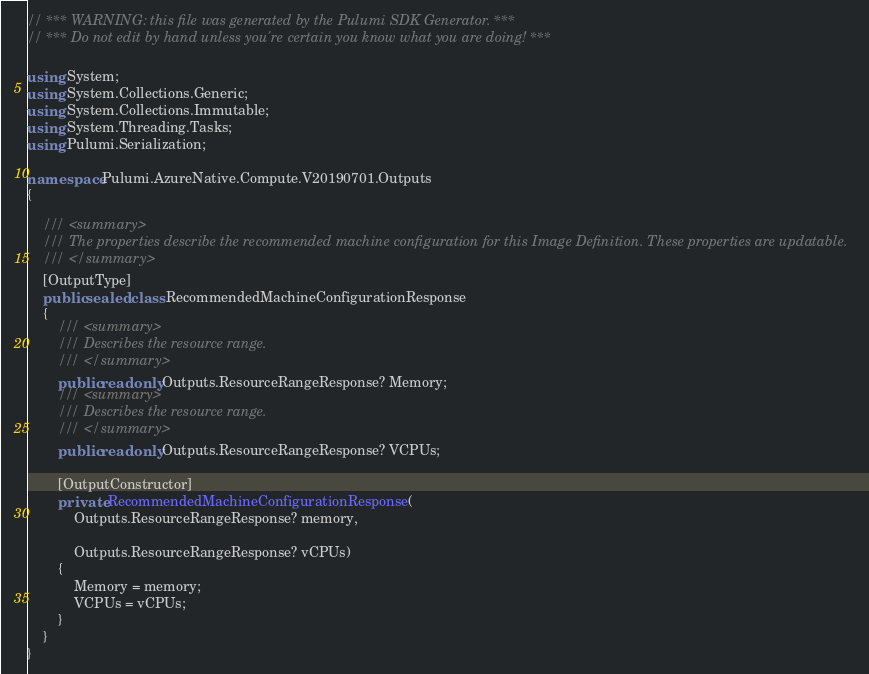Convert code to text. <code><loc_0><loc_0><loc_500><loc_500><_C#_>// *** WARNING: this file was generated by the Pulumi SDK Generator. ***
// *** Do not edit by hand unless you're certain you know what you are doing! ***

using System;
using System.Collections.Generic;
using System.Collections.Immutable;
using System.Threading.Tasks;
using Pulumi.Serialization;

namespace Pulumi.AzureNative.Compute.V20190701.Outputs
{

    /// <summary>
    /// The properties describe the recommended machine configuration for this Image Definition. These properties are updatable.
    /// </summary>
    [OutputType]
    public sealed class RecommendedMachineConfigurationResponse
    {
        /// <summary>
        /// Describes the resource range.
        /// </summary>
        public readonly Outputs.ResourceRangeResponse? Memory;
        /// <summary>
        /// Describes the resource range.
        /// </summary>
        public readonly Outputs.ResourceRangeResponse? VCPUs;

        [OutputConstructor]
        private RecommendedMachineConfigurationResponse(
            Outputs.ResourceRangeResponse? memory,

            Outputs.ResourceRangeResponse? vCPUs)
        {
            Memory = memory;
            VCPUs = vCPUs;
        }
    }
}
</code> 